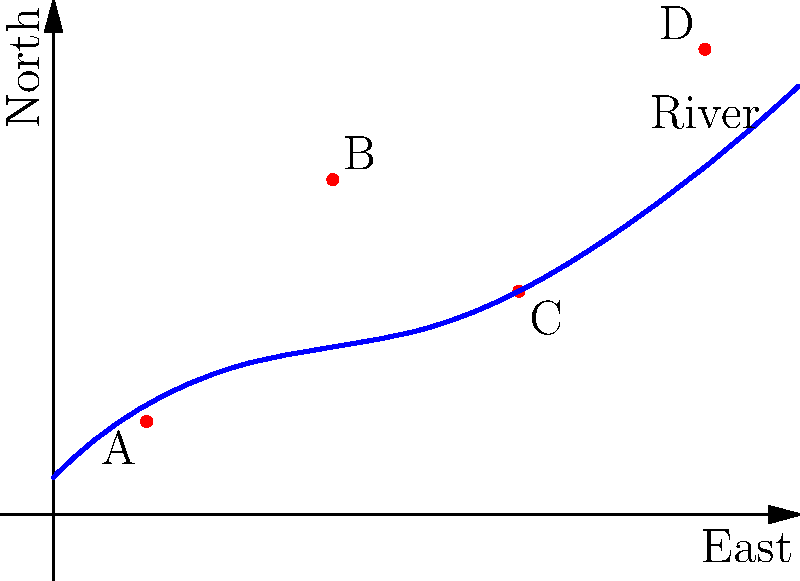The diagram represents early colonial settlements (A, B, C, and D) along a river in North America. Based on indigenous knowledge of local terrain, which settlement is most likely to face flooding issues during spring thaws, and why is this critical information for early settlers? To answer this question, we need to consider the relationship between the settlements and the river:

1. Analyze the positions of settlements relative to the river:
   A: Close to the river, at a low elevation
   B: Further from the river, at a higher elevation
   C: Close to the river, at a moderate elevation
   D: Further from the river, at the highest elevation

2. Consider the river's flow direction:
   The river flows from southwest to northeast, as indicated by its path on the coordinate system.

3. Evaluate flood risk factors:
   - Proximity to the river increases flood risk
   - Lower elevations are more susceptible to flooding
   - Areas downstream are at higher risk during spring thaws due to accumulated water flow

4. Identify the most at-risk settlement:
   Settlement A is closest to the river and at the lowest elevation, making it most susceptible to flooding.

5. Importance for early settlers:
   - Safety: Avoiding flood-prone areas ensures the safety of people and livestock
   - Agriculture: Fertile floodplains are beneficial for farming, but frequent flooding can destroy crops
   - Infrastructure: Building in flood-prone areas leads to property damage and resource waste
   - Long-term sustainability: Choosing safer locations promotes stable, long-lasting settlements

Indigenous knowledge of local terrain, including flood patterns, would have been crucial for early settlers in making informed decisions about settlement locations, potentially saving lives and resources.
Answer: Settlement A; critical for safety, agriculture, infrastructure, and long-term sustainability. 